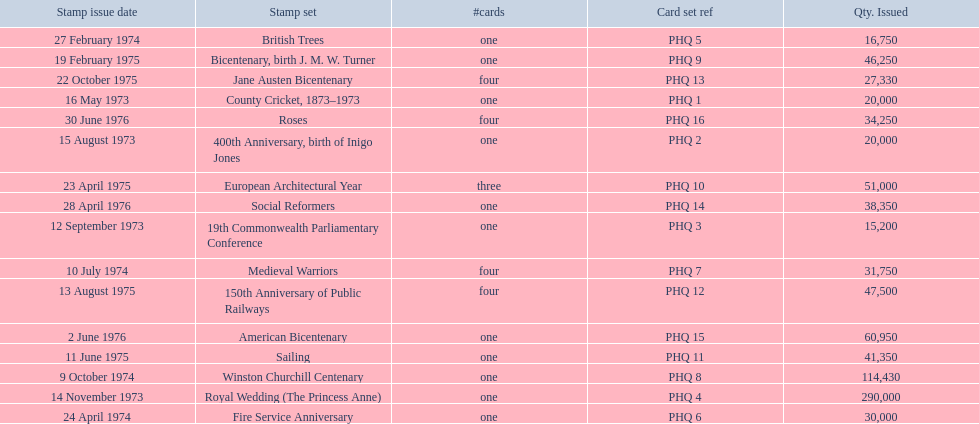How many stamp sets had at least 50,000 issued? 4. 